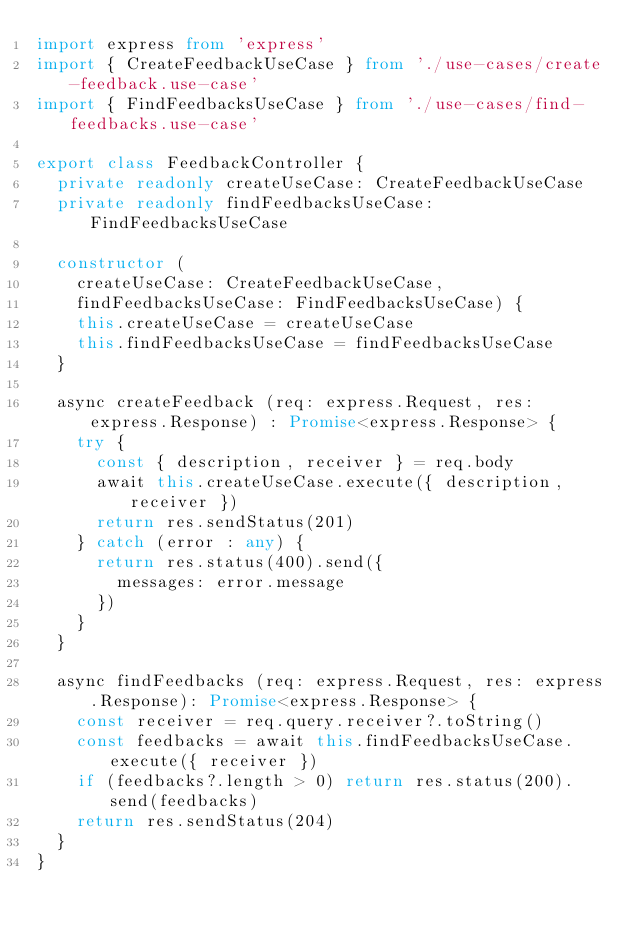Convert code to text. <code><loc_0><loc_0><loc_500><loc_500><_TypeScript_>import express from 'express'
import { CreateFeedbackUseCase } from './use-cases/create-feedback.use-case'
import { FindFeedbacksUseCase } from './use-cases/find-feedbacks.use-case'

export class FeedbackController {
  private readonly createUseCase: CreateFeedbackUseCase
  private readonly findFeedbacksUseCase: FindFeedbacksUseCase

  constructor (
    createUseCase: CreateFeedbackUseCase,
    findFeedbacksUseCase: FindFeedbacksUseCase) {
    this.createUseCase = createUseCase
    this.findFeedbacksUseCase = findFeedbacksUseCase
  }

  async createFeedback (req: express.Request, res: express.Response) : Promise<express.Response> {
    try {
      const { description, receiver } = req.body
      await this.createUseCase.execute({ description, receiver })
      return res.sendStatus(201)
    } catch (error : any) {
      return res.status(400).send({
        messages: error.message
      })
    }
  }

  async findFeedbacks (req: express.Request, res: express.Response): Promise<express.Response> {
    const receiver = req.query.receiver?.toString()
    const feedbacks = await this.findFeedbacksUseCase.execute({ receiver })
    if (feedbacks?.length > 0) return res.status(200).send(feedbacks)
    return res.sendStatus(204)
  }
}
</code> 